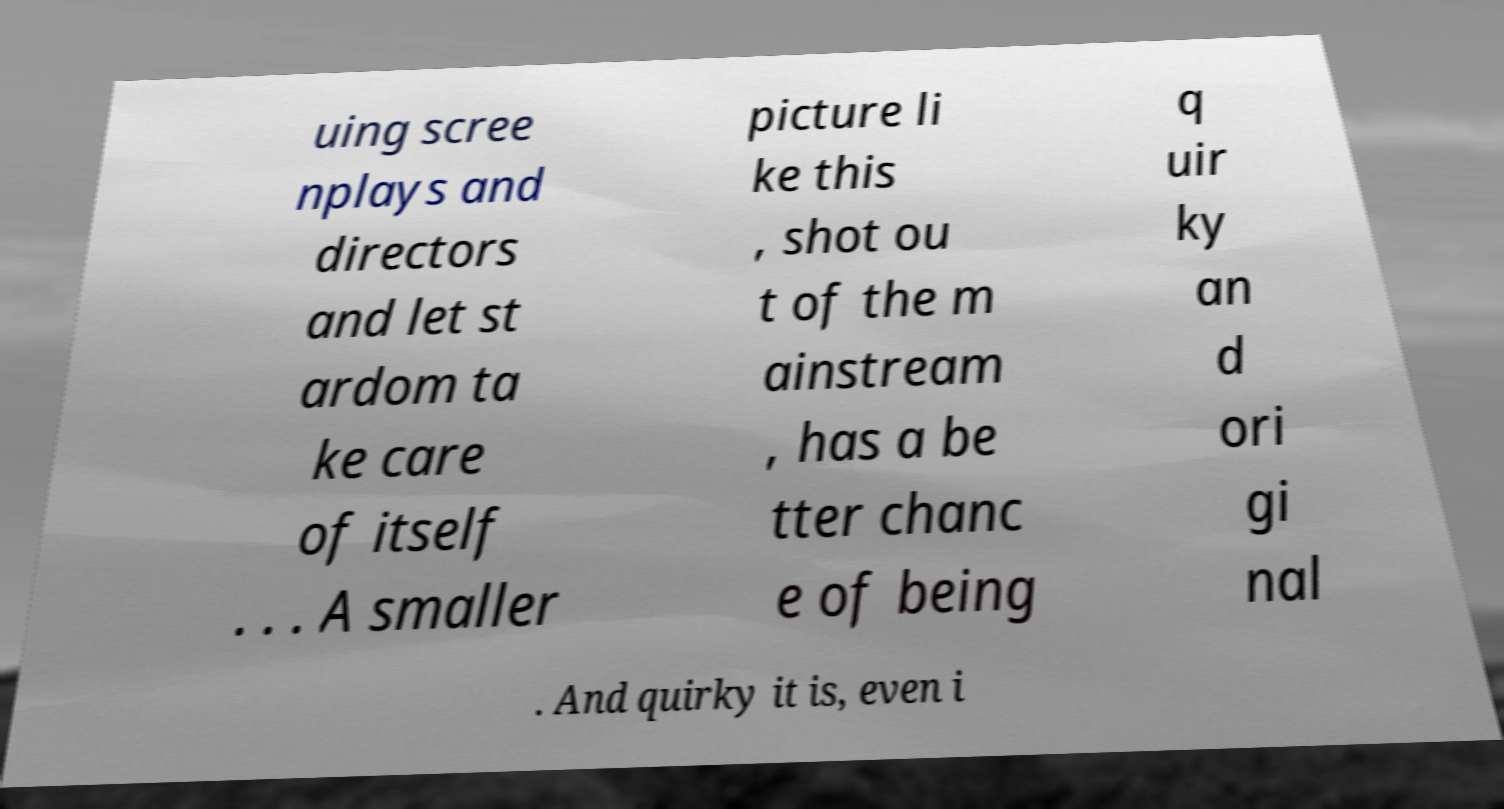Please identify and transcribe the text found in this image. uing scree nplays and directors and let st ardom ta ke care of itself . . . A smaller picture li ke this , shot ou t of the m ainstream , has a be tter chanc e of being q uir ky an d ori gi nal . And quirky it is, even i 